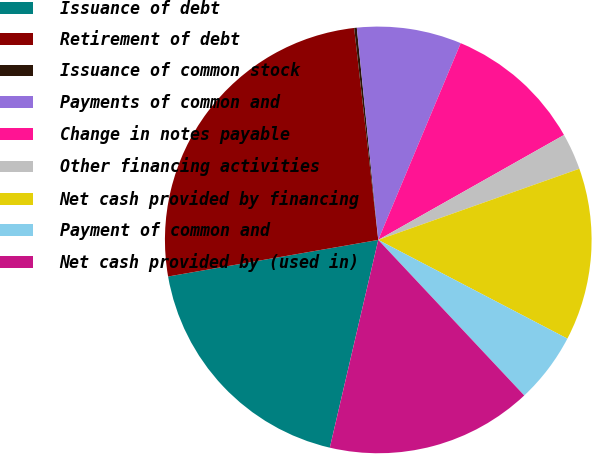Convert chart to OTSL. <chart><loc_0><loc_0><loc_500><loc_500><pie_chart><fcel>Issuance of debt<fcel>Retirement of debt<fcel>Issuance of common stock<fcel>Payments of common and<fcel>Change in notes payable<fcel>Other financing activities<fcel>Net cash provided by financing<fcel>Payment of common and<fcel>Net cash provided by (used in)<nl><fcel>18.61%<fcel>25.94%<fcel>0.2%<fcel>7.92%<fcel>10.5%<fcel>2.77%<fcel>13.07%<fcel>5.35%<fcel>15.64%<nl></chart> 